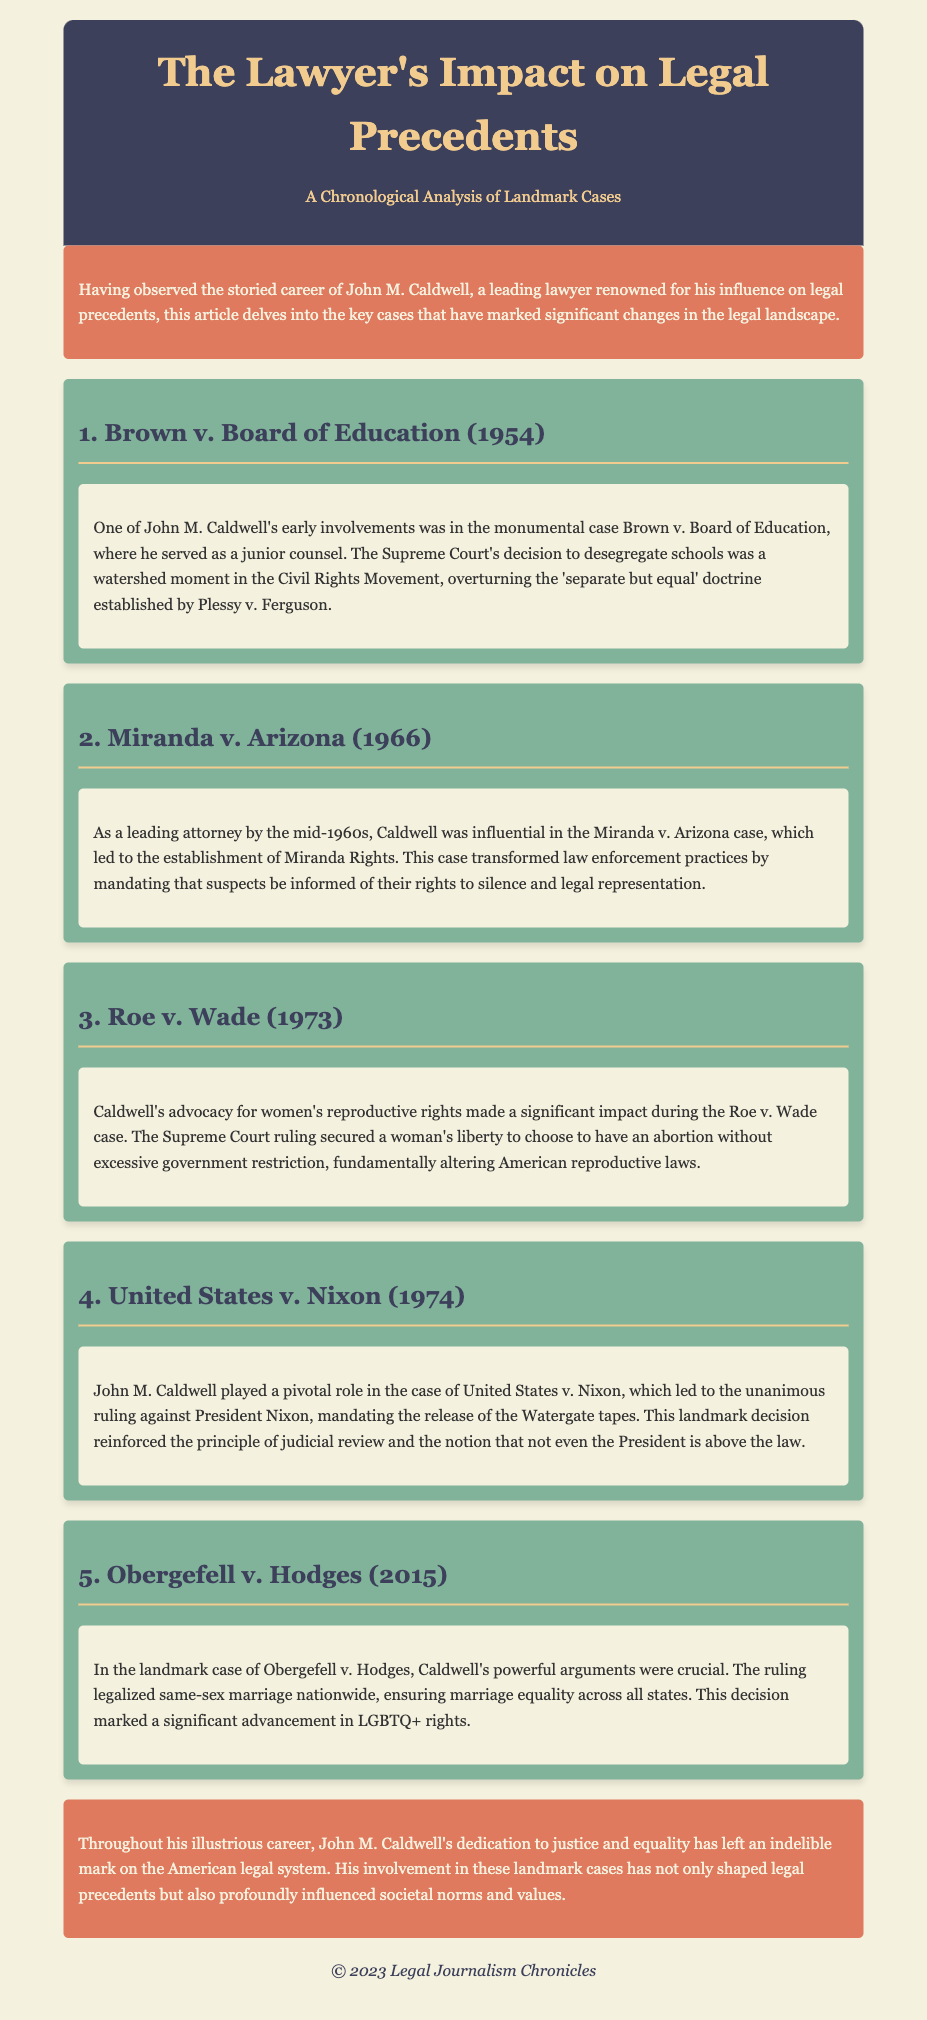What case did John M. Caldwell work on in 1954? The document states that Caldwell was involved in the case Brown v. Board of Education in 1954, where he served as a junior counsel.
Answer: Brown v. Board of Education What landmark decision was made in Roe v. Wade? The document indicates that the Supreme Court ruling in Roe v. Wade secured a woman's liberty to choose to have an abortion without excessive government restriction.
Answer: A woman's liberty to choose abortion What legal advancement did Obergefell v. Hodges achieve? According to the document, the Obergefell v. Hodges case legalized same-sex marriage nationwide.
Answer: Same-sex marriage legalization In which year did the case United States v. Nixon occur? The document specifies that the United States v. Nixon case was in 1974.
Answer: 1974 What significant impact did Caldwell have on Miranda v. Arizona? The document describes that Caldwell was influential in the case Miranda v. Arizona, establishing Miranda Rights, which mandated informing suspects of their rights.
Answer: Established Miranda Rights What overarching theme is emphasized in the conclusion about Caldwell's career? The conclusion highlights Caldwell's dedication to justice and equality, indicating that he has left an indelible mark on the American legal system.
Answer: Justice and equality How many significant cases are discussed in the document? The document outlines five significant cases that resulted in major legal changes involving John M. Caldwell.
Answer: Five What was the primary outcome of the case United States v. Nixon? The document states that the case led to a unanimous ruling against President Nixon, mandating the release of the Watergate tapes.
Answer: Release of the Watergate tapes What social movement is associated with Brown v. Board of Education? The document mentions that the decision in Brown v. Board of Education was a watershed moment in the Civil Rights Movement.
Answer: Civil Rights Movement 